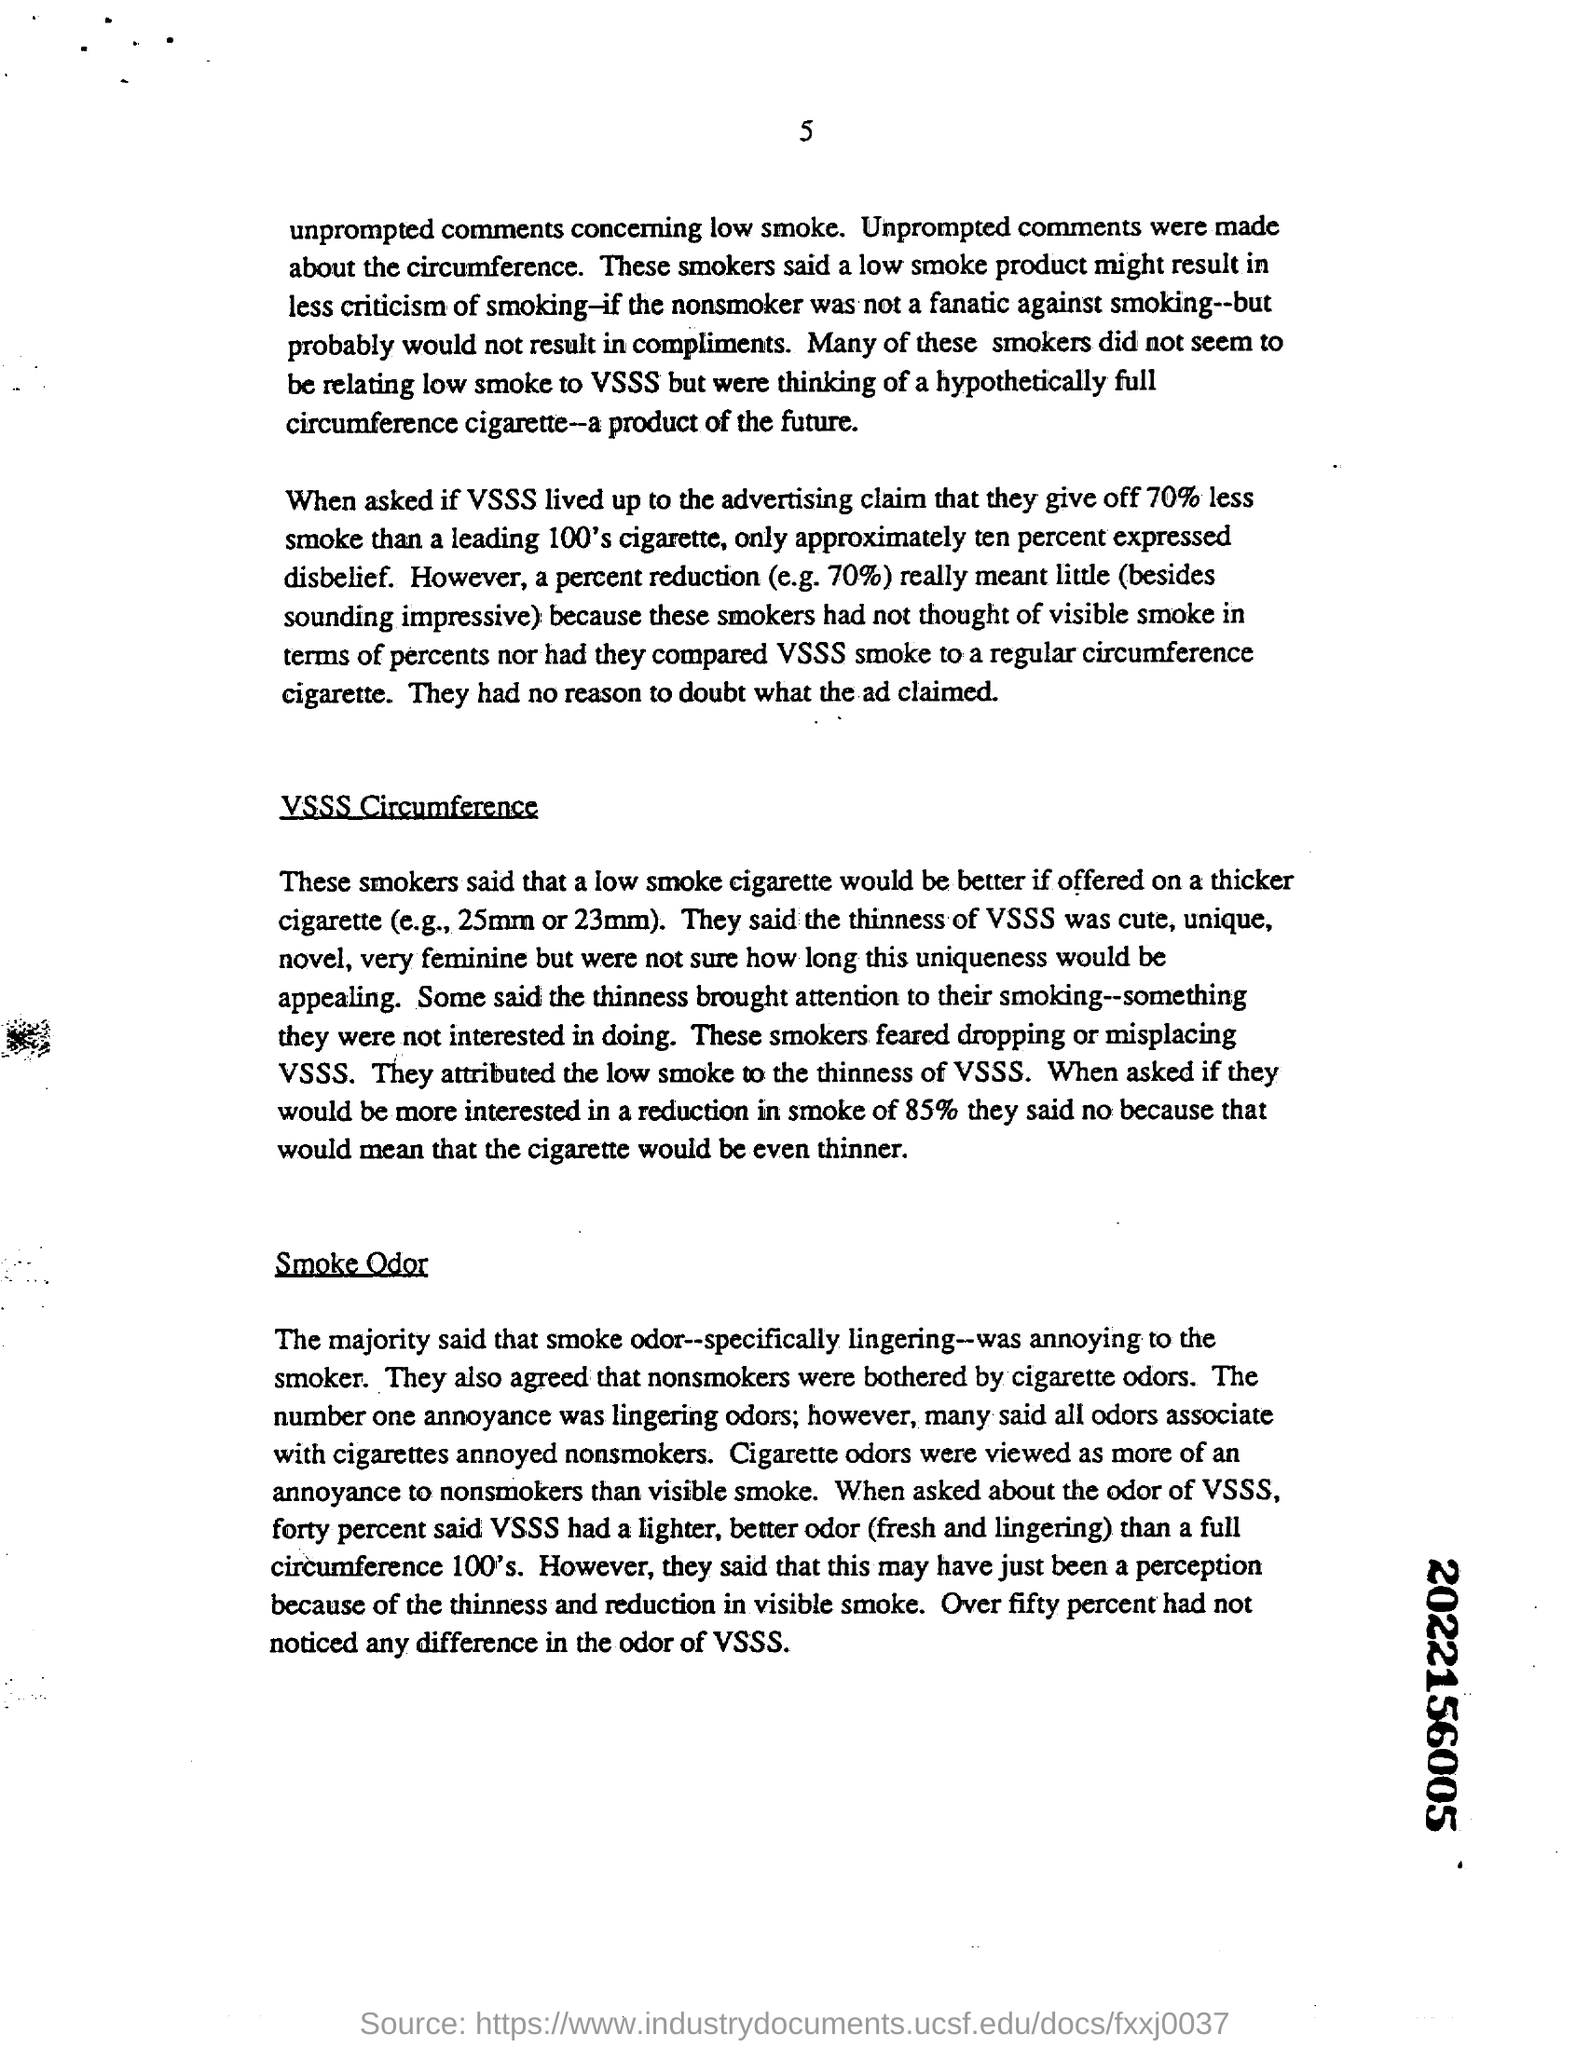Indicate a few pertinent items in this graphic. More than half of the participants did not notice any significant change in the odor of VSSS. Non-smokers who were bothered by cigarette odors made up the group of individuals in the study. A thicker cigarette would make a better cigarette if it were offered with a cigarette that is low in smoke. 